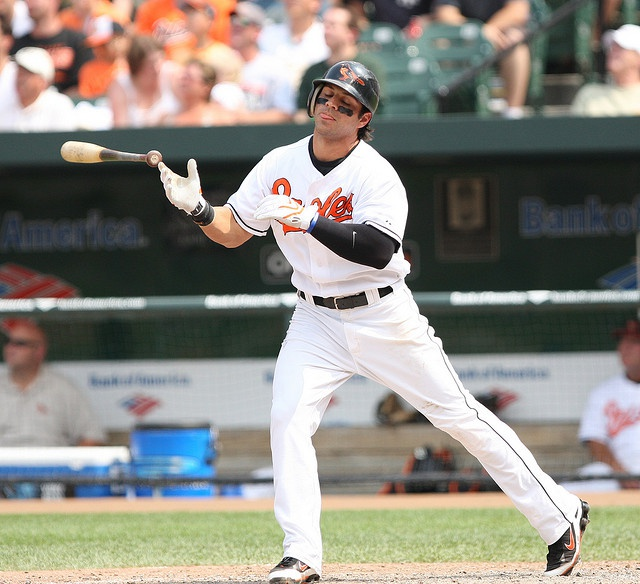Describe the objects in this image and their specific colors. I can see people in salmon, white, black, and gray tones, bench in salmon, gray, and darkgray tones, people in salmon, darkgray, and brown tones, chair in salmon, lightblue, and gray tones, and people in salmon, lavender, gray, brown, and darkgray tones in this image. 